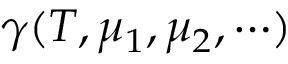Convert formula to latex. <formula><loc_0><loc_0><loc_500><loc_500>\gamma ( T , \mu _ { 1 } , \mu _ { 2 } , \cdots )</formula> 